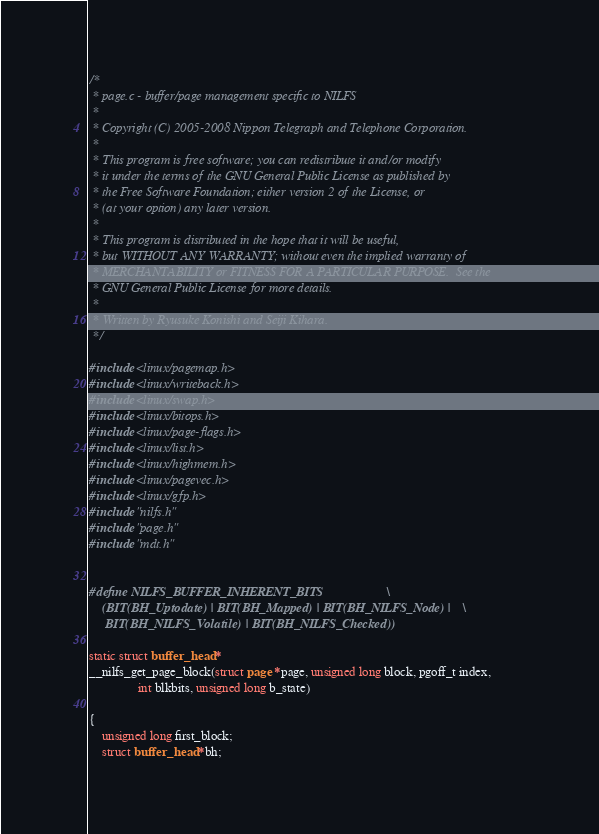Convert code to text. <code><loc_0><loc_0><loc_500><loc_500><_C_>/*
 * page.c - buffer/page management specific to NILFS
 *
 * Copyright (C) 2005-2008 Nippon Telegraph and Telephone Corporation.
 *
 * This program is free software; you can redistribute it and/or modify
 * it under the terms of the GNU General Public License as published by
 * the Free Software Foundation; either version 2 of the License, or
 * (at your option) any later version.
 *
 * This program is distributed in the hope that it will be useful,
 * but WITHOUT ANY WARRANTY; without even the implied warranty of
 * MERCHANTABILITY or FITNESS FOR A PARTICULAR PURPOSE.  See the
 * GNU General Public License for more details.
 *
 * Written by Ryusuke Konishi and Seiji Kihara.
 */

#include <linux/pagemap.h>
#include <linux/writeback.h>
#include <linux/swap.h>
#include <linux/bitops.h>
#include <linux/page-flags.h>
#include <linux/list.h>
#include <linux/highmem.h>
#include <linux/pagevec.h>
#include <linux/gfp.h>
#include "nilfs.h"
#include "page.h"
#include "mdt.h"


#define NILFS_BUFFER_INHERENT_BITS					\
	(BIT(BH_Uptodate) | BIT(BH_Mapped) | BIT(BH_NILFS_Node) |	\
	 BIT(BH_NILFS_Volatile) | BIT(BH_NILFS_Checked))

static struct buffer_head *
__nilfs_get_page_block(struct page *page, unsigned long block, pgoff_t index,
		       int blkbits, unsigned long b_state)

{
	unsigned long first_block;
	struct buffer_head *bh;
</code> 